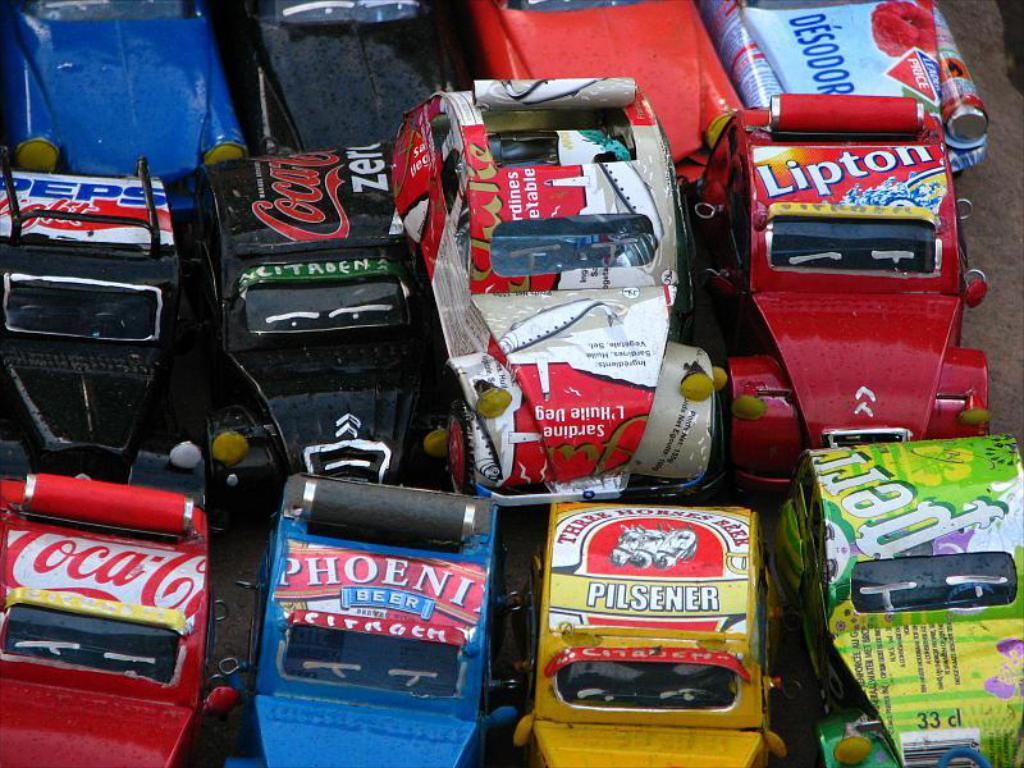Could you give a brief overview of what you see in this image? In this picture I can see toy vehicles on an object. 